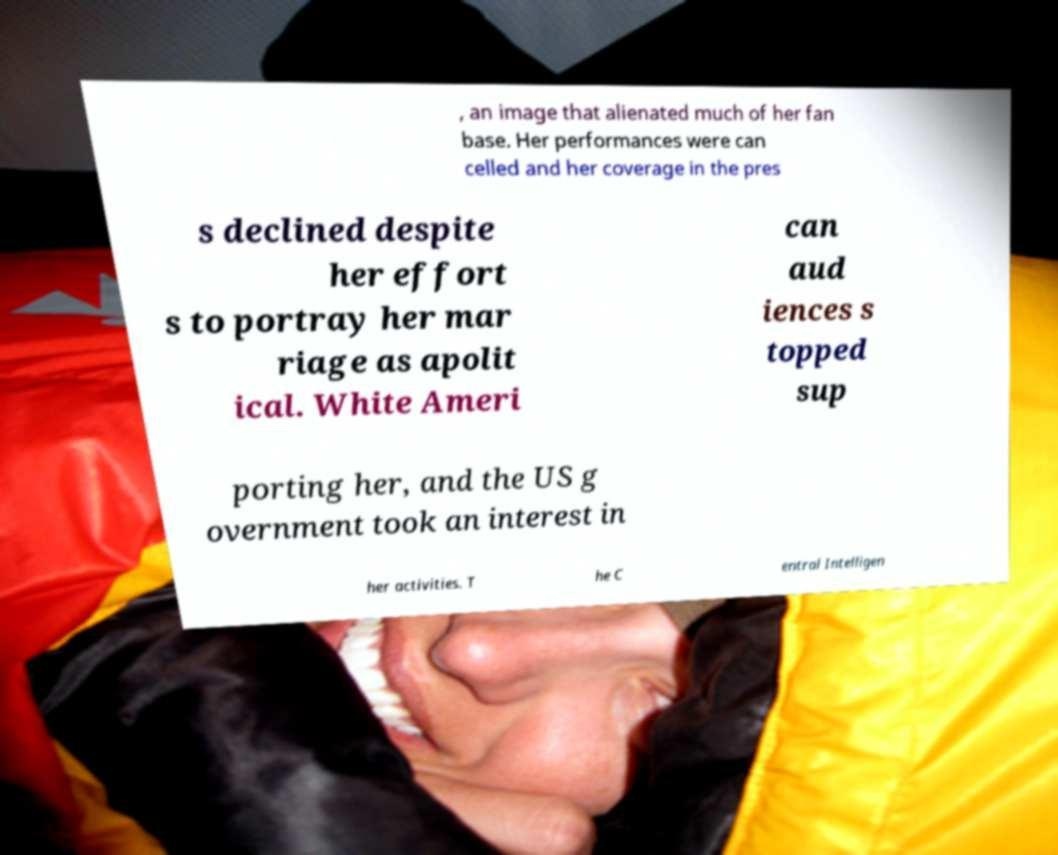There's text embedded in this image that I need extracted. Can you transcribe it verbatim? , an image that alienated much of her fan base. Her performances were can celled and her coverage in the pres s declined despite her effort s to portray her mar riage as apolit ical. White Ameri can aud iences s topped sup porting her, and the US g overnment took an interest in her activities. T he C entral Intelligen 